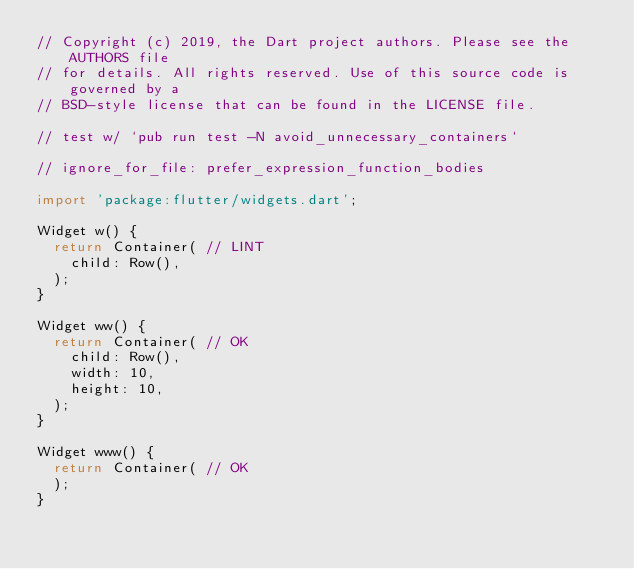Convert code to text. <code><loc_0><loc_0><loc_500><loc_500><_Dart_>// Copyright (c) 2019, the Dart project authors. Please see the AUTHORS file
// for details. All rights reserved. Use of this source code is governed by a
// BSD-style license that can be found in the LICENSE file.

// test w/ `pub run test -N avoid_unnecessary_containers`

// ignore_for_file: prefer_expression_function_bodies

import 'package:flutter/widgets.dart';

Widget w() {
  return Container( // LINT
    child: Row(),
  );
}

Widget ww() {
  return Container( // OK
    child: Row(),
    width: 10,
    height: 10,
  );
}

Widget www() {
  return Container( // OK
  );
}
</code> 